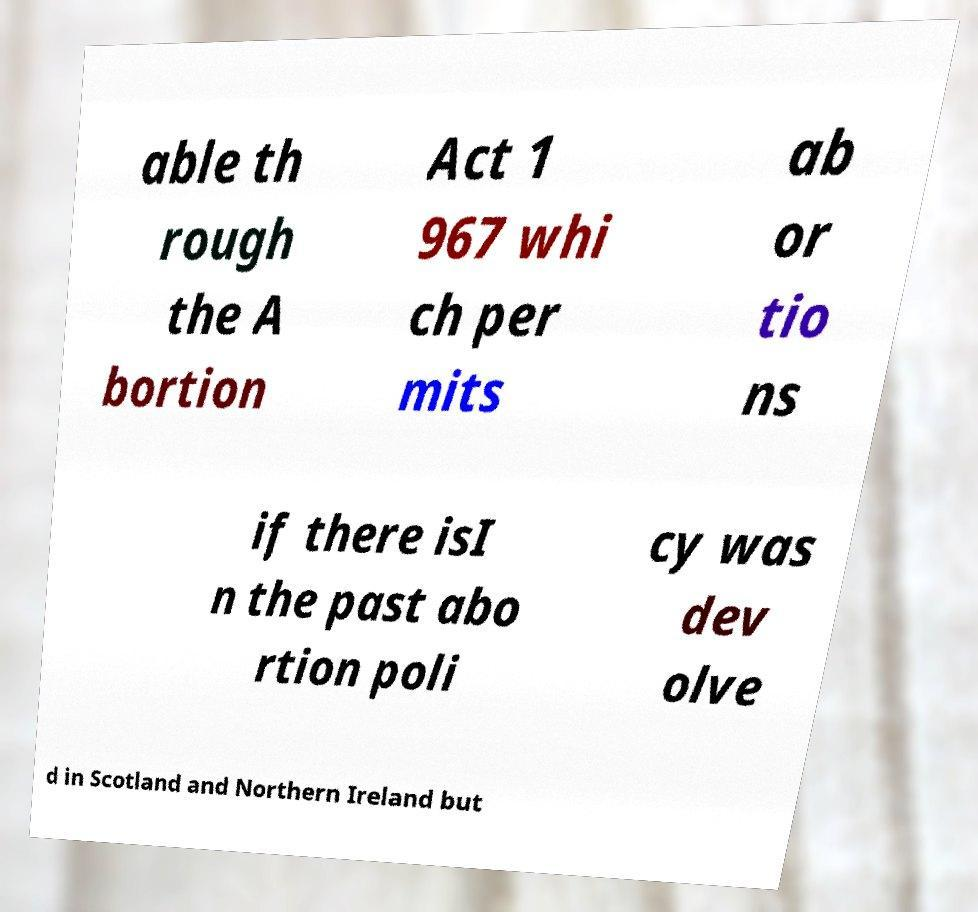Can you accurately transcribe the text from the provided image for me? able th rough the A bortion Act 1 967 whi ch per mits ab or tio ns if there isI n the past abo rtion poli cy was dev olve d in Scotland and Northern Ireland but 